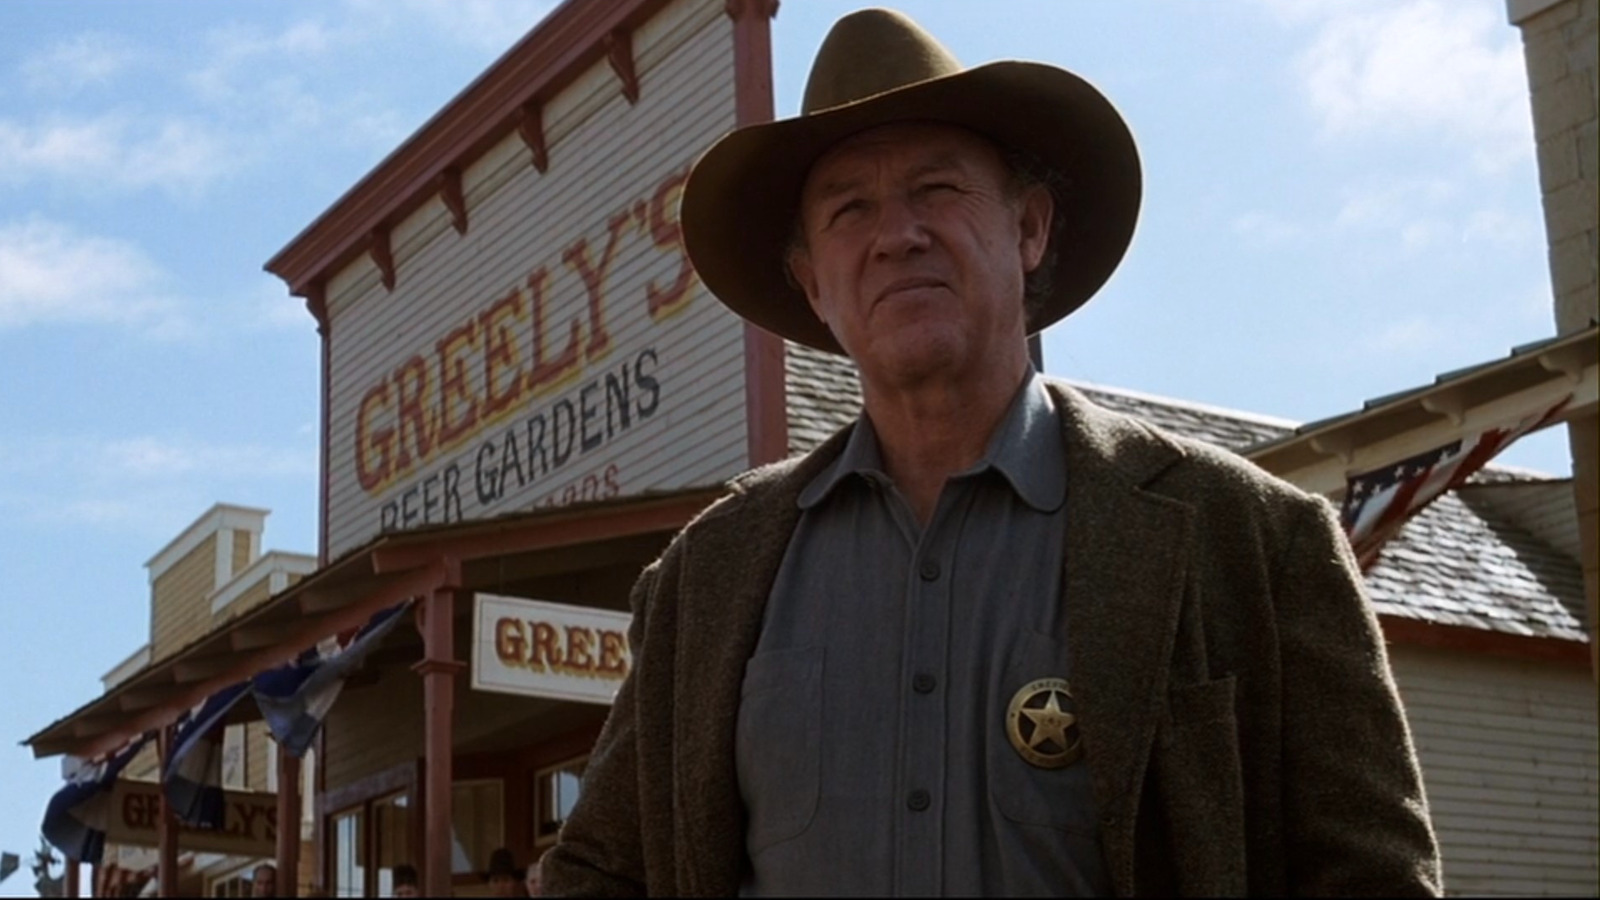Describe the person's clothing and what it might signify. The person is wearing a cowboy hat, a jacket with a tweed-like texture, a shirt, and a visible badge. The clothing and badge are reminiscent of what one might expect a law enforcement officer to wear in the American Wild West. The badge could indicate that the individual is playing the role of a sheriff or marshal in a historical recreation or a theatrical performance. 